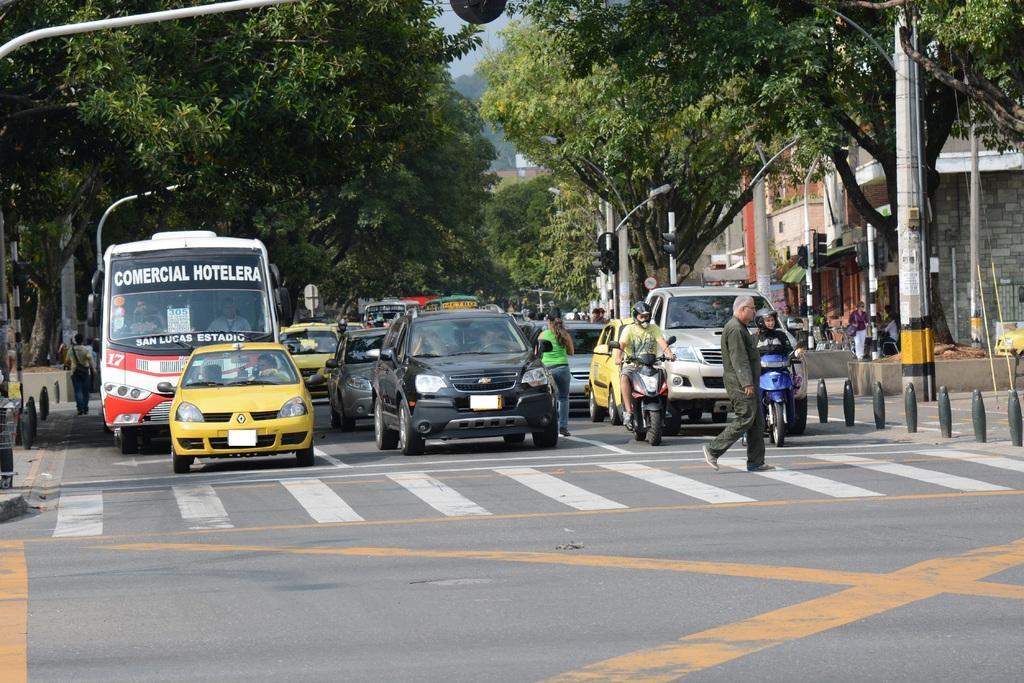Describe this image in one or two sentences. Vehicles and persons are on the road. Background there are signal light poles, buildings and trees. These two people are sitting on motorbikes. 